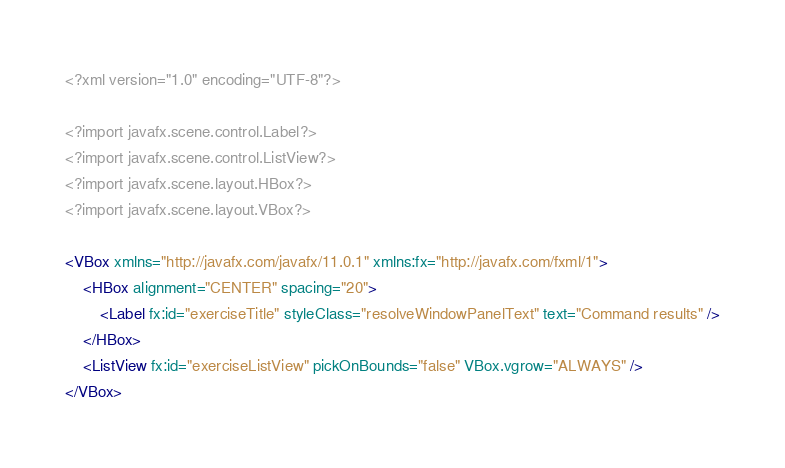<code> <loc_0><loc_0><loc_500><loc_500><_XML_><?xml version="1.0" encoding="UTF-8"?>

<?import javafx.scene.control.Label?>
<?import javafx.scene.control.ListView?>
<?import javafx.scene.layout.HBox?>
<?import javafx.scene.layout.VBox?>

<VBox xmlns="http://javafx.com/javafx/11.0.1" xmlns:fx="http://javafx.com/fxml/1">
    <HBox alignment="CENTER" spacing="20">
        <Label fx:id="exerciseTitle" styleClass="resolveWindowPanelText" text="Command results" />
    </HBox>
    <ListView fx:id="exerciseListView" pickOnBounds="false" VBox.vgrow="ALWAYS" />
</VBox>
</code> 